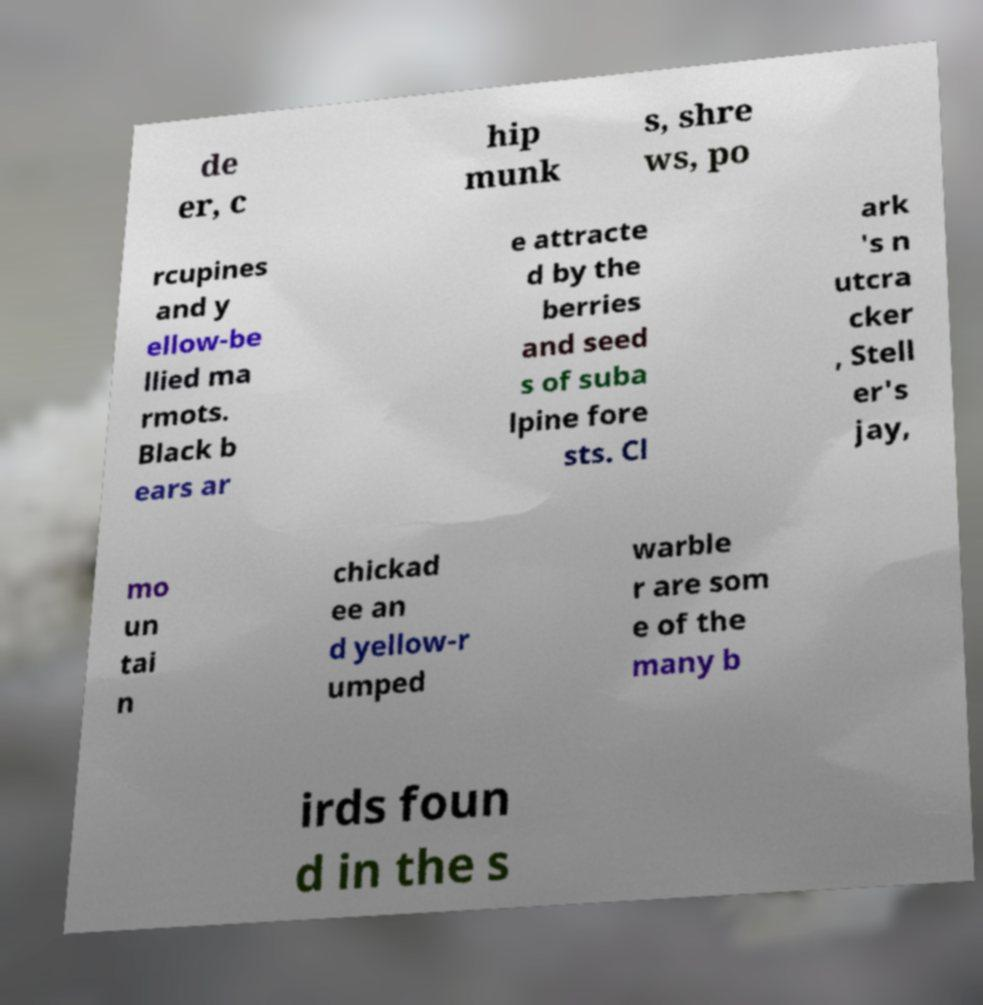What messages or text are displayed in this image? I need them in a readable, typed format. de er, c hip munk s, shre ws, po rcupines and y ellow-be llied ma rmots. Black b ears ar e attracte d by the berries and seed s of suba lpine fore sts. Cl ark 's n utcra cker , Stell er's jay, mo un tai n chickad ee an d yellow-r umped warble r are som e of the many b irds foun d in the s 